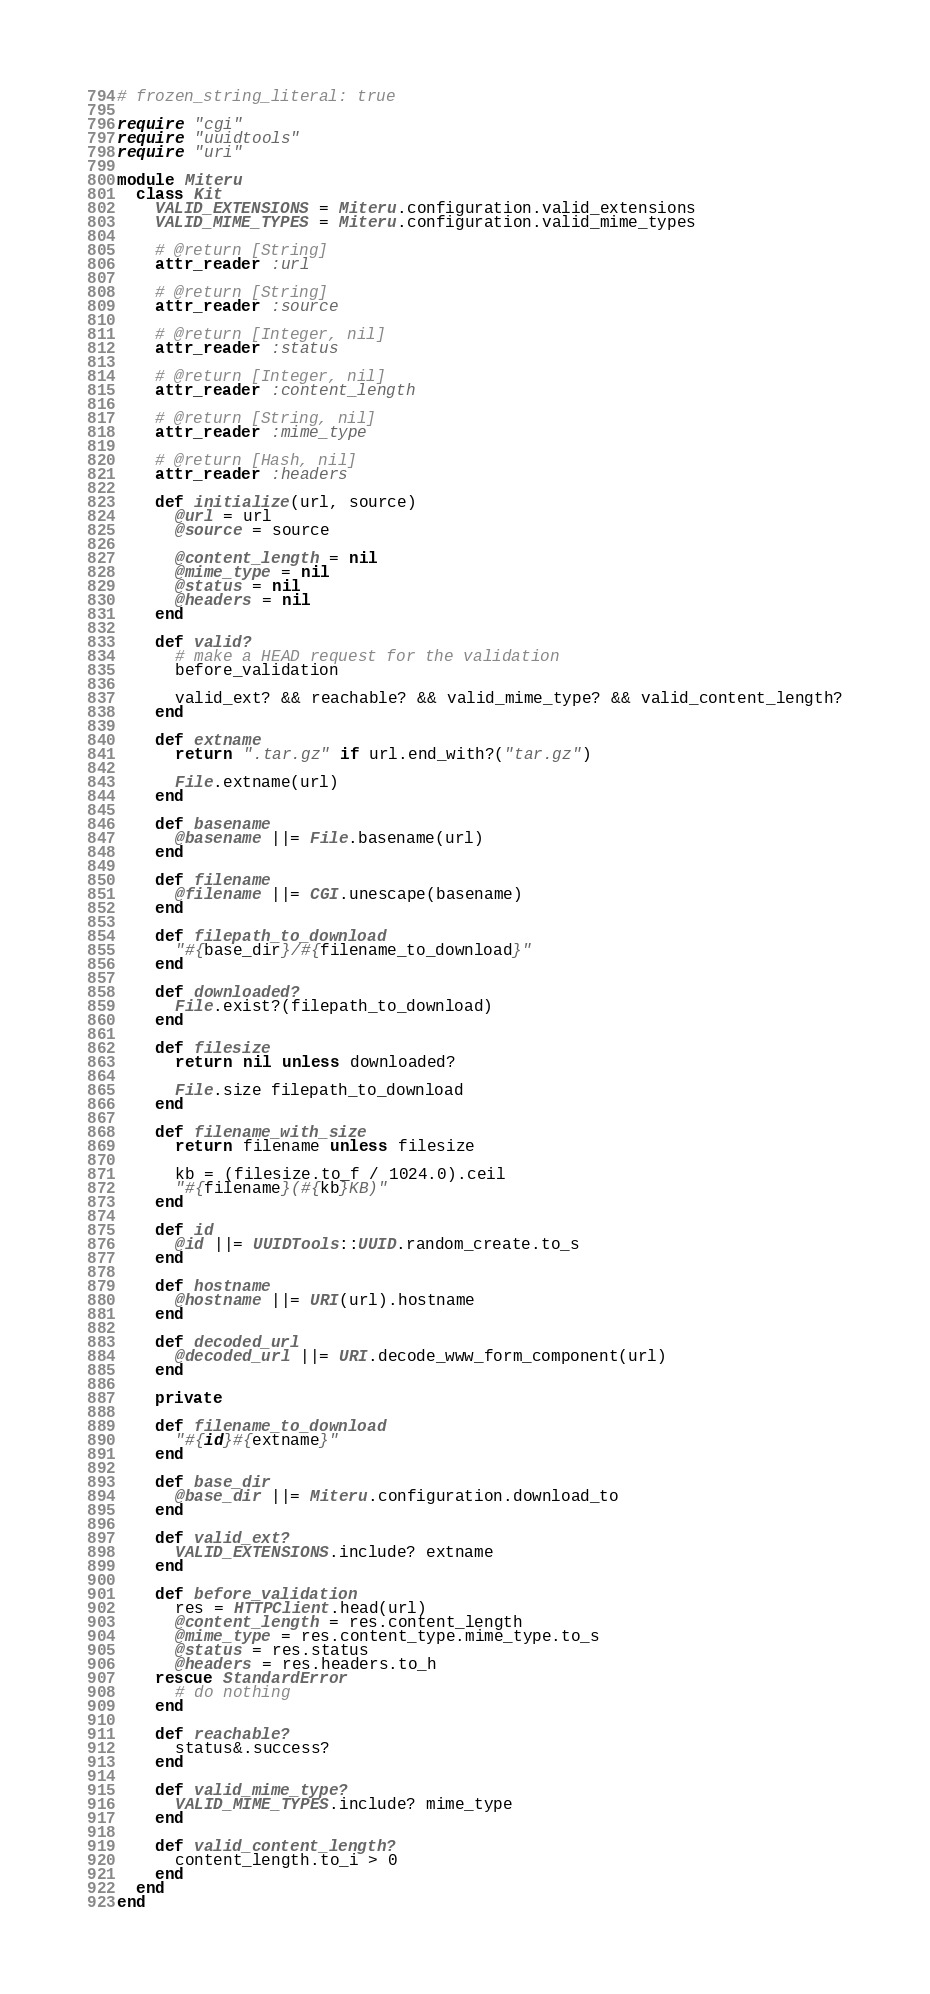Convert code to text. <code><loc_0><loc_0><loc_500><loc_500><_Ruby_># frozen_string_literal: true

require "cgi"
require "uuidtools"
require "uri"

module Miteru
  class Kit
    VALID_EXTENSIONS = Miteru.configuration.valid_extensions
    VALID_MIME_TYPES = Miteru.configuration.valid_mime_types

    # @return [String]
    attr_reader :url

    # @return [String]
    attr_reader :source

    # @return [Integer, nil]
    attr_reader :status

    # @return [Integer, nil]
    attr_reader :content_length

    # @return [String, nil]
    attr_reader :mime_type

    # @return [Hash, nil]
    attr_reader :headers

    def initialize(url, source)
      @url = url
      @source = source

      @content_length = nil
      @mime_type = nil
      @status = nil
      @headers = nil
    end

    def valid?
      # make a HEAD request for the validation
      before_validation

      valid_ext? && reachable? && valid_mime_type? && valid_content_length?
    end

    def extname
      return ".tar.gz" if url.end_with?("tar.gz")

      File.extname(url)
    end

    def basename
      @basename ||= File.basename(url)
    end

    def filename
      @filename ||= CGI.unescape(basename)
    end

    def filepath_to_download
      "#{base_dir}/#{filename_to_download}"
    end

    def downloaded?
      File.exist?(filepath_to_download)
    end

    def filesize
      return nil unless downloaded?

      File.size filepath_to_download
    end

    def filename_with_size
      return filename unless filesize

      kb = (filesize.to_f / 1024.0).ceil
      "#{filename}(#{kb}KB)"
    end

    def id
      @id ||= UUIDTools::UUID.random_create.to_s
    end

    def hostname
      @hostname ||= URI(url).hostname
    end

    def decoded_url
      @decoded_url ||= URI.decode_www_form_component(url)
    end

    private

    def filename_to_download
      "#{id}#{extname}"
    end

    def base_dir
      @base_dir ||= Miteru.configuration.download_to
    end

    def valid_ext?
      VALID_EXTENSIONS.include? extname
    end

    def before_validation
      res = HTTPClient.head(url)
      @content_length = res.content_length
      @mime_type = res.content_type.mime_type.to_s
      @status = res.status
      @headers = res.headers.to_h
    rescue StandardError
      # do nothing
    end

    def reachable?
      status&.success?
    end

    def valid_mime_type?
      VALID_MIME_TYPES.include? mime_type
    end

    def valid_content_length?
      content_length.to_i > 0
    end
  end
end
</code> 